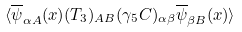Convert formula to latex. <formula><loc_0><loc_0><loc_500><loc_500>\langle \overline { \psi } _ { \alpha A } ( x ) ( T _ { 3 } ) _ { A B } ( \gamma _ { 5 } C ) _ { \alpha \beta } \overline { \psi } _ { \beta B } ( x ) \rangle \\</formula> 